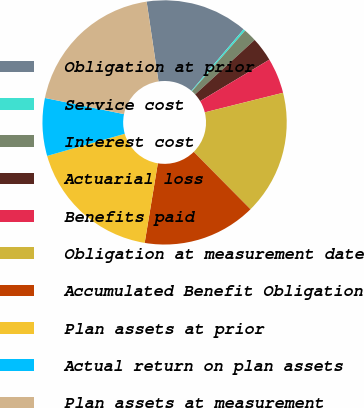<chart> <loc_0><loc_0><loc_500><loc_500><pie_chart><fcel>Obligation at prior<fcel>Service cost<fcel>Interest cost<fcel>Actuarial loss<fcel>Benefits paid<fcel>Obligation at measurement date<fcel>Accumulated Benefit Obligation<fcel>Plan assets at prior<fcel>Actual return on plan assets<fcel>Plan assets at measurement<nl><fcel>13.55%<fcel>0.26%<fcel>1.74%<fcel>3.21%<fcel>4.69%<fcel>16.49%<fcel>15.02%<fcel>17.97%<fcel>7.63%<fcel>19.44%<nl></chart> 